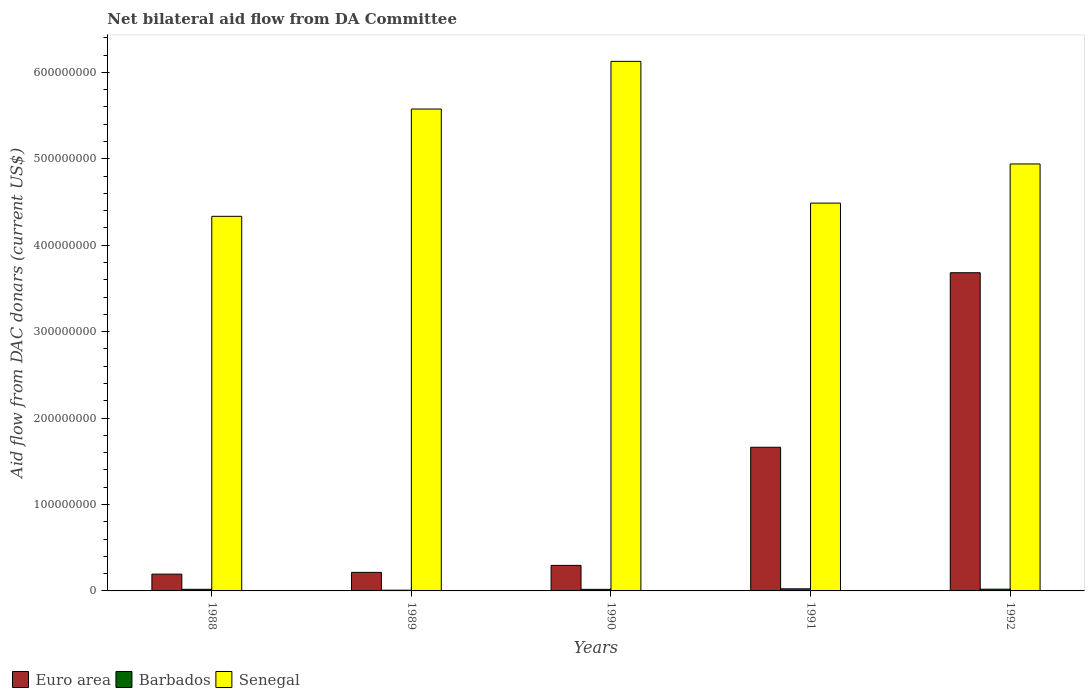How many different coloured bars are there?
Offer a terse response. 3. Are the number of bars per tick equal to the number of legend labels?
Provide a short and direct response. Yes. How many bars are there on the 4th tick from the left?
Your answer should be very brief. 3. What is the aid flow in in Barbados in 1989?
Your answer should be compact. 8.30e+05. Across all years, what is the maximum aid flow in in Barbados?
Offer a very short reply. 2.44e+06. Across all years, what is the minimum aid flow in in Euro area?
Ensure brevity in your answer.  1.94e+07. In which year was the aid flow in in Barbados minimum?
Give a very brief answer. 1989. What is the total aid flow in in Senegal in the graph?
Offer a terse response. 2.55e+09. What is the difference between the aid flow in in Euro area in 1988 and that in 1989?
Your answer should be compact. -2.04e+06. What is the difference between the aid flow in in Euro area in 1989 and the aid flow in in Senegal in 1991?
Your answer should be compact. -4.27e+08. What is the average aid flow in in Euro area per year?
Your answer should be very brief. 1.21e+08. In the year 1988, what is the difference between the aid flow in in Senegal and aid flow in in Barbados?
Offer a very short reply. 4.32e+08. In how many years, is the aid flow in in Barbados greater than 260000000 US$?
Ensure brevity in your answer.  0. What is the ratio of the aid flow in in Euro area in 1990 to that in 1992?
Offer a terse response. 0.08. Is the aid flow in in Barbados in 1990 less than that in 1992?
Offer a very short reply. Yes. Is the difference between the aid flow in in Senegal in 1990 and 1992 greater than the difference between the aid flow in in Barbados in 1990 and 1992?
Your response must be concise. Yes. What is the difference between the highest and the second highest aid flow in in Senegal?
Your answer should be very brief. 5.52e+07. What is the difference between the highest and the lowest aid flow in in Euro area?
Give a very brief answer. 3.49e+08. What does the 1st bar from the left in 1991 represents?
Your answer should be very brief. Euro area. What does the 2nd bar from the right in 1990 represents?
Give a very brief answer. Barbados. How many bars are there?
Provide a short and direct response. 15. Are all the bars in the graph horizontal?
Provide a succinct answer. No. Are the values on the major ticks of Y-axis written in scientific E-notation?
Your answer should be compact. No. Does the graph contain any zero values?
Provide a short and direct response. No. Where does the legend appear in the graph?
Your response must be concise. Bottom left. How many legend labels are there?
Provide a succinct answer. 3. How are the legend labels stacked?
Offer a terse response. Horizontal. What is the title of the graph?
Ensure brevity in your answer.  Net bilateral aid flow from DA Committee. What is the label or title of the X-axis?
Offer a terse response. Years. What is the label or title of the Y-axis?
Offer a terse response. Aid flow from DAC donars (current US$). What is the Aid flow from DAC donars (current US$) of Euro area in 1988?
Provide a short and direct response. 1.94e+07. What is the Aid flow from DAC donars (current US$) in Barbados in 1988?
Your response must be concise. 1.85e+06. What is the Aid flow from DAC donars (current US$) in Senegal in 1988?
Your answer should be very brief. 4.33e+08. What is the Aid flow from DAC donars (current US$) in Euro area in 1989?
Keep it short and to the point. 2.15e+07. What is the Aid flow from DAC donars (current US$) of Barbados in 1989?
Ensure brevity in your answer.  8.30e+05. What is the Aid flow from DAC donars (current US$) in Senegal in 1989?
Your answer should be compact. 5.58e+08. What is the Aid flow from DAC donars (current US$) of Euro area in 1990?
Give a very brief answer. 2.96e+07. What is the Aid flow from DAC donars (current US$) of Barbados in 1990?
Your answer should be very brief. 1.82e+06. What is the Aid flow from DAC donars (current US$) in Senegal in 1990?
Your answer should be very brief. 6.13e+08. What is the Aid flow from DAC donars (current US$) of Euro area in 1991?
Your response must be concise. 1.66e+08. What is the Aid flow from DAC donars (current US$) in Barbados in 1991?
Offer a very short reply. 2.44e+06. What is the Aid flow from DAC donars (current US$) in Senegal in 1991?
Your answer should be very brief. 4.49e+08. What is the Aid flow from DAC donars (current US$) of Euro area in 1992?
Ensure brevity in your answer.  3.68e+08. What is the Aid flow from DAC donars (current US$) in Barbados in 1992?
Your answer should be compact. 2.01e+06. What is the Aid flow from DAC donars (current US$) in Senegal in 1992?
Your answer should be compact. 4.94e+08. Across all years, what is the maximum Aid flow from DAC donars (current US$) in Euro area?
Your answer should be very brief. 3.68e+08. Across all years, what is the maximum Aid flow from DAC donars (current US$) of Barbados?
Offer a very short reply. 2.44e+06. Across all years, what is the maximum Aid flow from DAC donars (current US$) of Senegal?
Keep it short and to the point. 6.13e+08. Across all years, what is the minimum Aid flow from DAC donars (current US$) in Euro area?
Ensure brevity in your answer.  1.94e+07. Across all years, what is the minimum Aid flow from DAC donars (current US$) of Barbados?
Ensure brevity in your answer.  8.30e+05. Across all years, what is the minimum Aid flow from DAC donars (current US$) in Senegal?
Offer a terse response. 4.33e+08. What is the total Aid flow from DAC donars (current US$) in Euro area in the graph?
Your answer should be very brief. 6.05e+08. What is the total Aid flow from DAC donars (current US$) in Barbados in the graph?
Make the answer very short. 8.95e+06. What is the total Aid flow from DAC donars (current US$) in Senegal in the graph?
Make the answer very short. 2.55e+09. What is the difference between the Aid flow from DAC donars (current US$) in Euro area in 1988 and that in 1989?
Your answer should be very brief. -2.04e+06. What is the difference between the Aid flow from DAC donars (current US$) of Barbados in 1988 and that in 1989?
Provide a short and direct response. 1.02e+06. What is the difference between the Aid flow from DAC donars (current US$) of Senegal in 1988 and that in 1989?
Your answer should be compact. -1.24e+08. What is the difference between the Aid flow from DAC donars (current US$) in Euro area in 1988 and that in 1990?
Provide a succinct answer. -1.01e+07. What is the difference between the Aid flow from DAC donars (current US$) in Barbados in 1988 and that in 1990?
Ensure brevity in your answer.  3.00e+04. What is the difference between the Aid flow from DAC donars (current US$) in Senegal in 1988 and that in 1990?
Provide a succinct answer. -1.79e+08. What is the difference between the Aid flow from DAC donars (current US$) of Euro area in 1988 and that in 1991?
Offer a very short reply. -1.47e+08. What is the difference between the Aid flow from DAC donars (current US$) in Barbados in 1988 and that in 1991?
Your response must be concise. -5.90e+05. What is the difference between the Aid flow from DAC donars (current US$) in Senegal in 1988 and that in 1991?
Offer a terse response. -1.53e+07. What is the difference between the Aid flow from DAC donars (current US$) of Euro area in 1988 and that in 1992?
Your response must be concise. -3.49e+08. What is the difference between the Aid flow from DAC donars (current US$) of Senegal in 1988 and that in 1992?
Your answer should be very brief. -6.06e+07. What is the difference between the Aid flow from DAC donars (current US$) of Euro area in 1989 and that in 1990?
Ensure brevity in your answer.  -8.09e+06. What is the difference between the Aid flow from DAC donars (current US$) in Barbados in 1989 and that in 1990?
Offer a very short reply. -9.90e+05. What is the difference between the Aid flow from DAC donars (current US$) in Senegal in 1989 and that in 1990?
Your answer should be very brief. -5.52e+07. What is the difference between the Aid flow from DAC donars (current US$) of Euro area in 1989 and that in 1991?
Your answer should be very brief. -1.45e+08. What is the difference between the Aid flow from DAC donars (current US$) of Barbados in 1989 and that in 1991?
Provide a short and direct response. -1.61e+06. What is the difference between the Aid flow from DAC donars (current US$) in Senegal in 1989 and that in 1991?
Offer a terse response. 1.09e+08. What is the difference between the Aid flow from DAC donars (current US$) in Euro area in 1989 and that in 1992?
Keep it short and to the point. -3.47e+08. What is the difference between the Aid flow from DAC donars (current US$) of Barbados in 1989 and that in 1992?
Make the answer very short. -1.18e+06. What is the difference between the Aid flow from DAC donars (current US$) of Senegal in 1989 and that in 1992?
Provide a succinct answer. 6.36e+07. What is the difference between the Aid flow from DAC donars (current US$) in Euro area in 1990 and that in 1991?
Provide a short and direct response. -1.37e+08. What is the difference between the Aid flow from DAC donars (current US$) in Barbados in 1990 and that in 1991?
Give a very brief answer. -6.20e+05. What is the difference between the Aid flow from DAC donars (current US$) in Senegal in 1990 and that in 1991?
Keep it short and to the point. 1.64e+08. What is the difference between the Aid flow from DAC donars (current US$) in Euro area in 1990 and that in 1992?
Your answer should be very brief. -3.39e+08. What is the difference between the Aid flow from DAC donars (current US$) of Barbados in 1990 and that in 1992?
Make the answer very short. -1.90e+05. What is the difference between the Aid flow from DAC donars (current US$) in Senegal in 1990 and that in 1992?
Your answer should be compact. 1.19e+08. What is the difference between the Aid flow from DAC donars (current US$) in Euro area in 1991 and that in 1992?
Your answer should be very brief. -2.02e+08. What is the difference between the Aid flow from DAC donars (current US$) in Senegal in 1991 and that in 1992?
Keep it short and to the point. -4.53e+07. What is the difference between the Aid flow from DAC donars (current US$) in Euro area in 1988 and the Aid flow from DAC donars (current US$) in Barbados in 1989?
Your answer should be compact. 1.86e+07. What is the difference between the Aid flow from DAC donars (current US$) of Euro area in 1988 and the Aid flow from DAC donars (current US$) of Senegal in 1989?
Your answer should be very brief. -5.38e+08. What is the difference between the Aid flow from DAC donars (current US$) in Barbados in 1988 and the Aid flow from DAC donars (current US$) in Senegal in 1989?
Ensure brevity in your answer.  -5.56e+08. What is the difference between the Aid flow from DAC donars (current US$) in Euro area in 1988 and the Aid flow from DAC donars (current US$) in Barbados in 1990?
Provide a short and direct response. 1.76e+07. What is the difference between the Aid flow from DAC donars (current US$) of Euro area in 1988 and the Aid flow from DAC donars (current US$) of Senegal in 1990?
Ensure brevity in your answer.  -5.93e+08. What is the difference between the Aid flow from DAC donars (current US$) of Barbados in 1988 and the Aid flow from DAC donars (current US$) of Senegal in 1990?
Make the answer very short. -6.11e+08. What is the difference between the Aid flow from DAC donars (current US$) in Euro area in 1988 and the Aid flow from DAC donars (current US$) in Barbados in 1991?
Your response must be concise. 1.70e+07. What is the difference between the Aid flow from DAC donars (current US$) in Euro area in 1988 and the Aid flow from DAC donars (current US$) in Senegal in 1991?
Provide a succinct answer. -4.29e+08. What is the difference between the Aid flow from DAC donars (current US$) in Barbados in 1988 and the Aid flow from DAC donars (current US$) in Senegal in 1991?
Provide a succinct answer. -4.47e+08. What is the difference between the Aid flow from DAC donars (current US$) in Euro area in 1988 and the Aid flow from DAC donars (current US$) in Barbados in 1992?
Your answer should be compact. 1.74e+07. What is the difference between the Aid flow from DAC donars (current US$) in Euro area in 1988 and the Aid flow from DAC donars (current US$) in Senegal in 1992?
Offer a very short reply. -4.75e+08. What is the difference between the Aid flow from DAC donars (current US$) in Barbados in 1988 and the Aid flow from DAC donars (current US$) in Senegal in 1992?
Your answer should be compact. -4.92e+08. What is the difference between the Aid flow from DAC donars (current US$) of Euro area in 1989 and the Aid flow from DAC donars (current US$) of Barbados in 1990?
Your answer should be very brief. 1.96e+07. What is the difference between the Aid flow from DAC donars (current US$) in Euro area in 1989 and the Aid flow from DAC donars (current US$) in Senegal in 1990?
Provide a short and direct response. -5.91e+08. What is the difference between the Aid flow from DAC donars (current US$) in Barbados in 1989 and the Aid flow from DAC donars (current US$) in Senegal in 1990?
Keep it short and to the point. -6.12e+08. What is the difference between the Aid flow from DAC donars (current US$) in Euro area in 1989 and the Aid flow from DAC donars (current US$) in Barbados in 1991?
Your response must be concise. 1.90e+07. What is the difference between the Aid flow from DAC donars (current US$) in Euro area in 1989 and the Aid flow from DAC donars (current US$) in Senegal in 1991?
Make the answer very short. -4.27e+08. What is the difference between the Aid flow from DAC donars (current US$) of Barbados in 1989 and the Aid flow from DAC donars (current US$) of Senegal in 1991?
Provide a short and direct response. -4.48e+08. What is the difference between the Aid flow from DAC donars (current US$) of Euro area in 1989 and the Aid flow from DAC donars (current US$) of Barbados in 1992?
Ensure brevity in your answer.  1.95e+07. What is the difference between the Aid flow from DAC donars (current US$) of Euro area in 1989 and the Aid flow from DAC donars (current US$) of Senegal in 1992?
Your response must be concise. -4.73e+08. What is the difference between the Aid flow from DAC donars (current US$) of Barbados in 1989 and the Aid flow from DAC donars (current US$) of Senegal in 1992?
Provide a succinct answer. -4.93e+08. What is the difference between the Aid flow from DAC donars (current US$) in Euro area in 1990 and the Aid flow from DAC donars (current US$) in Barbados in 1991?
Your response must be concise. 2.71e+07. What is the difference between the Aid flow from DAC donars (current US$) of Euro area in 1990 and the Aid flow from DAC donars (current US$) of Senegal in 1991?
Your response must be concise. -4.19e+08. What is the difference between the Aid flow from DAC donars (current US$) in Barbados in 1990 and the Aid flow from DAC donars (current US$) in Senegal in 1991?
Keep it short and to the point. -4.47e+08. What is the difference between the Aid flow from DAC donars (current US$) of Euro area in 1990 and the Aid flow from DAC donars (current US$) of Barbados in 1992?
Keep it short and to the point. 2.76e+07. What is the difference between the Aid flow from DAC donars (current US$) of Euro area in 1990 and the Aid flow from DAC donars (current US$) of Senegal in 1992?
Offer a terse response. -4.65e+08. What is the difference between the Aid flow from DAC donars (current US$) of Barbados in 1990 and the Aid flow from DAC donars (current US$) of Senegal in 1992?
Give a very brief answer. -4.92e+08. What is the difference between the Aid flow from DAC donars (current US$) of Euro area in 1991 and the Aid flow from DAC donars (current US$) of Barbados in 1992?
Your answer should be compact. 1.64e+08. What is the difference between the Aid flow from DAC donars (current US$) in Euro area in 1991 and the Aid flow from DAC donars (current US$) in Senegal in 1992?
Ensure brevity in your answer.  -3.28e+08. What is the difference between the Aid flow from DAC donars (current US$) of Barbados in 1991 and the Aid flow from DAC donars (current US$) of Senegal in 1992?
Provide a succinct answer. -4.92e+08. What is the average Aid flow from DAC donars (current US$) in Euro area per year?
Offer a terse response. 1.21e+08. What is the average Aid flow from DAC donars (current US$) in Barbados per year?
Provide a short and direct response. 1.79e+06. What is the average Aid flow from DAC donars (current US$) of Senegal per year?
Give a very brief answer. 5.09e+08. In the year 1988, what is the difference between the Aid flow from DAC donars (current US$) of Euro area and Aid flow from DAC donars (current US$) of Barbados?
Your answer should be compact. 1.76e+07. In the year 1988, what is the difference between the Aid flow from DAC donars (current US$) in Euro area and Aid flow from DAC donars (current US$) in Senegal?
Keep it short and to the point. -4.14e+08. In the year 1988, what is the difference between the Aid flow from DAC donars (current US$) of Barbados and Aid flow from DAC donars (current US$) of Senegal?
Provide a succinct answer. -4.32e+08. In the year 1989, what is the difference between the Aid flow from DAC donars (current US$) of Euro area and Aid flow from DAC donars (current US$) of Barbados?
Offer a very short reply. 2.06e+07. In the year 1989, what is the difference between the Aid flow from DAC donars (current US$) in Euro area and Aid flow from DAC donars (current US$) in Senegal?
Keep it short and to the point. -5.36e+08. In the year 1989, what is the difference between the Aid flow from DAC donars (current US$) in Barbados and Aid flow from DAC donars (current US$) in Senegal?
Give a very brief answer. -5.57e+08. In the year 1990, what is the difference between the Aid flow from DAC donars (current US$) of Euro area and Aid flow from DAC donars (current US$) of Barbados?
Provide a succinct answer. 2.77e+07. In the year 1990, what is the difference between the Aid flow from DAC donars (current US$) of Euro area and Aid flow from DAC donars (current US$) of Senegal?
Your response must be concise. -5.83e+08. In the year 1990, what is the difference between the Aid flow from DAC donars (current US$) in Barbados and Aid flow from DAC donars (current US$) in Senegal?
Provide a succinct answer. -6.11e+08. In the year 1991, what is the difference between the Aid flow from DAC donars (current US$) of Euro area and Aid flow from DAC donars (current US$) of Barbados?
Offer a terse response. 1.64e+08. In the year 1991, what is the difference between the Aid flow from DAC donars (current US$) of Euro area and Aid flow from DAC donars (current US$) of Senegal?
Offer a terse response. -2.83e+08. In the year 1991, what is the difference between the Aid flow from DAC donars (current US$) of Barbados and Aid flow from DAC donars (current US$) of Senegal?
Offer a terse response. -4.46e+08. In the year 1992, what is the difference between the Aid flow from DAC donars (current US$) of Euro area and Aid flow from DAC donars (current US$) of Barbados?
Your response must be concise. 3.66e+08. In the year 1992, what is the difference between the Aid flow from DAC donars (current US$) in Euro area and Aid flow from DAC donars (current US$) in Senegal?
Your response must be concise. -1.26e+08. In the year 1992, what is the difference between the Aid flow from DAC donars (current US$) in Barbados and Aid flow from DAC donars (current US$) in Senegal?
Provide a succinct answer. -4.92e+08. What is the ratio of the Aid flow from DAC donars (current US$) in Euro area in 1988 to that in 1989?
Give a very brief answer. 0.91. What is the ratio of the Aid flow from DAC donars (current US$) in Barbados in 1988 to that in 1989?
Give a very brief answer. 2.23. What is the ratio of the Aid flow from DAC donars (current US$) of Senegal in 1988 to that in 1989?
Your answer should be compact. 0.78. What is the ratio of the Aid flow from DAC donars (current US$) of Euro area in 1988 to that in 1990?
Ensure brevity in your answer.  0.66. What is the ratio of the Aid flow from DAC donars (current US$) in Barbados in 1988 to that in 1990?
Offer a terse response. 1.02. What is the ratio of the Aid flow from DAC donars (current US$) of Senegal in 1988 to that in 1990?
Offer a terse response. 0.71. What is the ratio of the Aid flow from DAC donars (current US$) in Euro area in 1988 to that in 1991?
Provide a short and direct response. 0.12. What is the ratio of the Aid flow from DAC donars (current US$) of Barbados in 1988 to that in 1991?
Offer a very short reply. 0.76. What is the ratio of the Aid flow from DAC donars (current US$) in Euro area in 1988 to that in 1992?
Your answer should be very brief. 0.05. What is the ratio of the Aid flow from DAC donars (current US$) in Barbados in 1988 to that in 1992?
Ensure brevity in your answer.  0.92. What is the ratio of the Aid flow from DAC donars (current US$) of Senegal in 1988 to that in 1992?
Provide a succinct answer. 0.88. What is the ratio of the Aid flow from DAC donars (current US$) in Euro area in 1989 to that in 1990?
Ensure brevity in your answer.  0.73. What is the ratio of the Aid flow from DAC donars (current US$) in Barbados in 1989 to that in 1990?
Offer a very short reply. 0.46. What is the ratio of the Aid flow from DAC donars (current US$) in Senegal in 1989 to that in 1990?
Your answer should be very brief. 0.91. What is the ratio of the Aid flow from DAC donars (current US$) in Euro area in 1989 to that in 1991?
Offer a terse response. 0.13. What is the ratio of the Aid flow from DAC donars (current US$) of Barbados in 1989 to that in 1991?
Ensure brevity in your answer.  0.34. What is the ratio of the Aid flow from DAC donars (current US$) in Senegal in 1989 to that in 1991?
Offer a terse response. 1.24. What is the ratio of the Aid flow from DAC donars (current US$) in Euro area in 1989 to that in 1992?
Offer a terse response. 0.06. What is the ratio of the Aid flow from DAC donars (current US$) of Barbados in 1989 to that in 1992?
Your answer should be compact. 0.41. What is the ratio of the Aid flow from DAC donars (current US$) in Senegal in 1989 to that in 1992?
Make the answer very short. 1.13. What is the ratio of the Aid flow from DAC donars (current US$) of Euro area in 1990 to that in 1991?
Your response must be concise. 0.18. What is the ratio of the Aid flow from DAC donars (current US$) in Barbados in 1990 to that in 1991?
Make the answer very short. 0.75. What is the ratio of the Aid flow from DAC donars (current US$) in Senegal in 1990 to that in 1991?
Keep it short and to the point. 1.37. What is the ratio of the Aid flow from DAC donars (current US$) in Euro area in 1990 to that in 1992?
Provide a short and direct response. 0.08. What is the ratio of the Aid flow from DAC donars (current US$) of Barbados in 1990 to that in 1992?
Offer a very short reply. 0.91. What is the ratio of the Aid flow from DAC donars (current US$) of Senegal in 1990 to that in 1992?
Make the answer very short. 1.24. What is the ratio of the Aid flow from DAC donars (current US$) of Euro area in 1991 to that in 1992?
Make the answer very short. 0.45. What is the ratio of the Aid flow from DAC donars (current US$) in Barbados in 1991 to that in 1992?
Offer a terse response. 1.21. What is the ratio of the Aid flow from DAC donars (current US$) in Senegal in 1991 to that in 1992?
Your answer should be very brief. 0.91. What is the difference between the highest and the second highest Aid flow from DAC donars (current US$) in Euro area?
Your response must be concise. 2.02e+08. What is the difference between the highest and the second highest Aid flow from DAC donars (current US$) of Barbados?
Give a very brief answer. 4.30e+05. What is the difference between the highest and the second highest Aid flow from DAC donars (current US$) of Senegal?
Your answer should be very brief. 5.52e+07. What is the difference between the highest and the lowest Aid flow from DAC donars (current US$) of Euro area?
Your answer should be compact. 3.49e+08. What is the difference between the highest and the lowest Aid flow from DAC donars (current US$) of Barbados?
Provide a short and direct response. 1.61e+06. What is the difference between the highest and the lowest Aid flow from DAC donars (current US$) of Senegal?
Your answer should be very brief. 1.79e+08. 